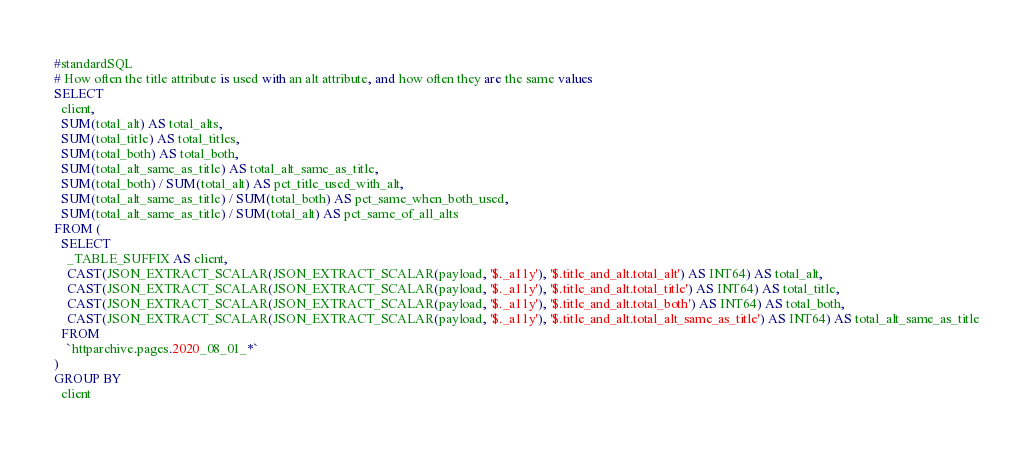Convert code to text. <code><loc_0><loc_0><loc_500><loc_500><_SQL_>#standardSQL
# How often the title attribute is used with an alt attribute, and how often they are the same values
SELECT
  client,
  SUM(total_alt) AS total_alts,
  SUM(total_title) AS total_titles,
  SUM(total_both) AS total_both,
  SUM(total_alt_same_as_title) AS total_alt_same_as_title,
  SUM(total_both) / SUM(total_alt) AS pct_title_used_with_alt,
  SUM(total_alt_same_as_title) / SUM(total_both) AS pct_same_when_both_used,
  SUM(total_alt_same_as_title) / SUM(total_alt) AS pct_same_of_all_alts
FROM (
  SELECT
    _TABLE_SUFFIX AS client,
    CAST(JSON_EXTRACT_SCALAR(JSON_EXTRACT_SCALAR(payload, '$._a11y'), '$.title_and_alt.total_alt') AS INT64) AS total_alt,
    CAST(JSON_EXTRACT_SCALAR(JSON_EXTRACT_SCALAR(payload, '$._a11y'), '$.title_and_alt.total_title') AS INT64) AS total_title,
    CAST(JSON_EXTRACT_SCALAR(JSON_EXTRACT_SCALAR(payload, '$._a11y'), '$.title_and_alt.total_both') AS INT64) AS total_both,
    CAST(JSON_EXTRACT_SCALAR(JSON_EXTRACT_SCALAR(payload, '$._a11y'), '$.title_and_alt.total_alt_same_as_title') AS INT64) AS total_alt_same_as_title
  FROM
    `httparchive.pages.2020_08_01_*`
)
GROUP BY
  client
</code> 